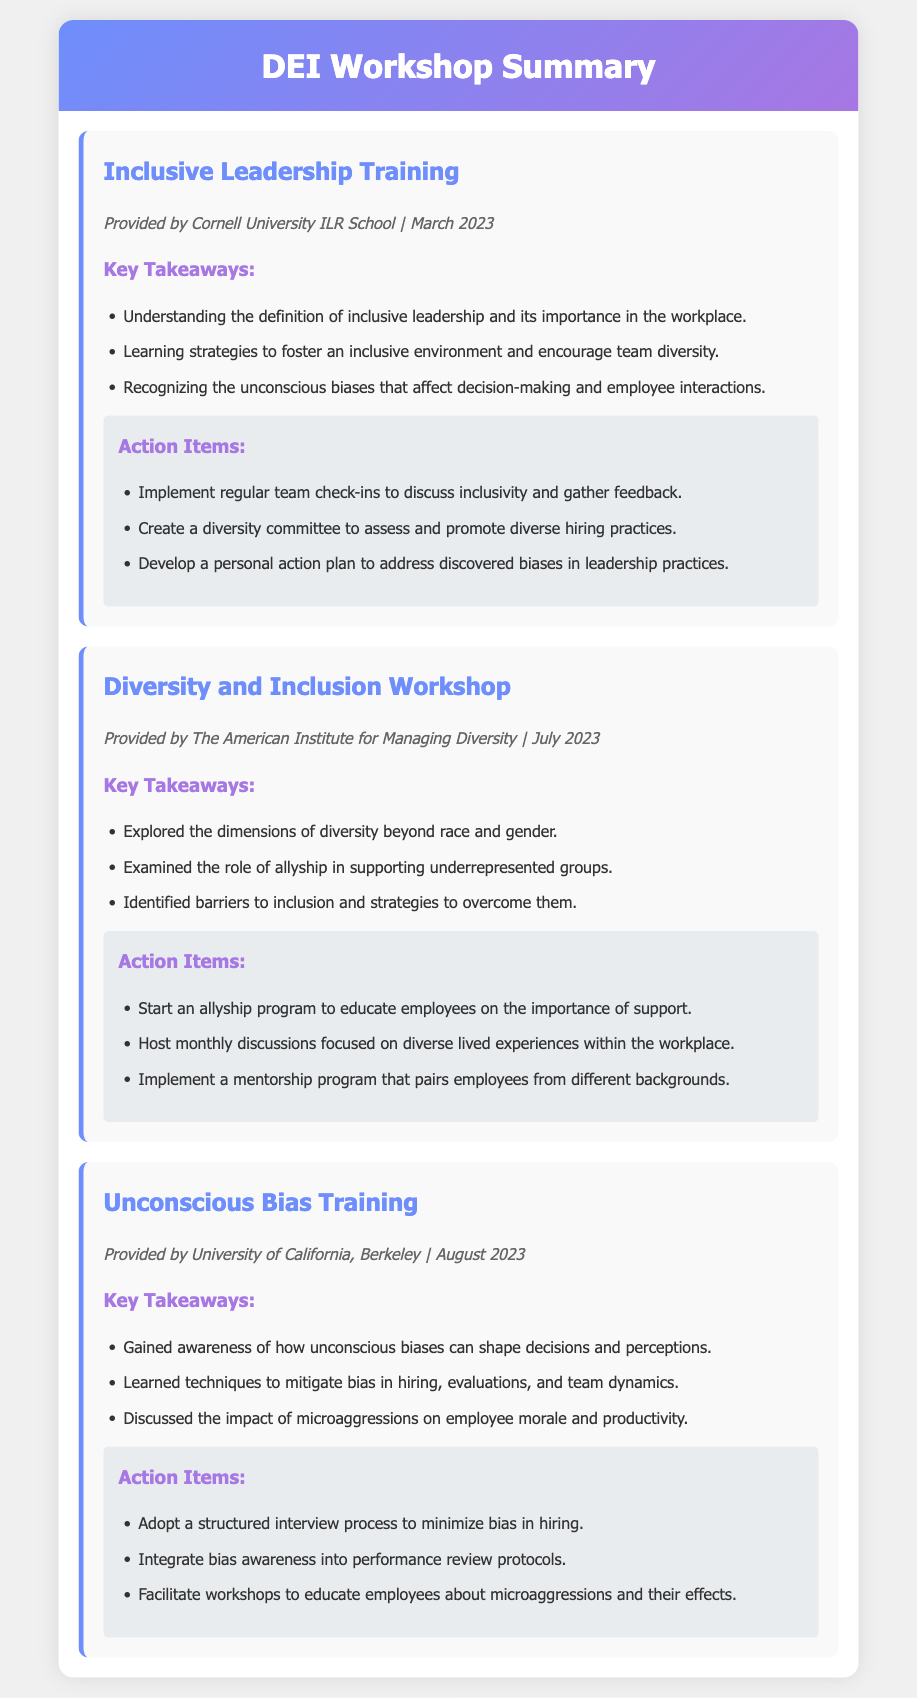What is the title of the first workshop? The title is the name displayed at the beginning of each workshop section in the document, which is "Inclusive Leadership Training."
Answer: Inclusive Leadership Training Who provided the Diversity and Inclusion Workshop? The provider is mentioned in the meta section of the workshop, which states "The American Institute for Managing Diversity."
Answer: The American Institute for Managing Diversity How many key takeaways are listed for the Unconscious Bias Training? The number of key takeaways is counted from the bullet points under the key takeaways section, which lists three items.
Answer: 3 What is one action item from the Inclusive Leadership Training? Action items are outlined in their respective sections, one listed item is "Implement regular team check-ins to discuss inclusivity and gather feedback."
Answer: Implement regular team check-ins to discuss inclusivity and gather feedback Which month was the Unconscious Bias Training conducted? The month is found in the meta section of the workshop, stating "August 2023."
Answer: August What common theme is present in the action items across workshops? To identify a common theme, we review the action items, many promote discussions or programs that emphasize inclusivity and diversity, such as "Start an allyship program."
Answer: Promote discussions or programs focusing on inclusivity and diversity 